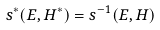<formula> <loc_0><loc_0><loc_500><loc_500>s ^ { * } ( E , H ^ { * } ) = s ^ { - 1 } ( E , H )</formula> 